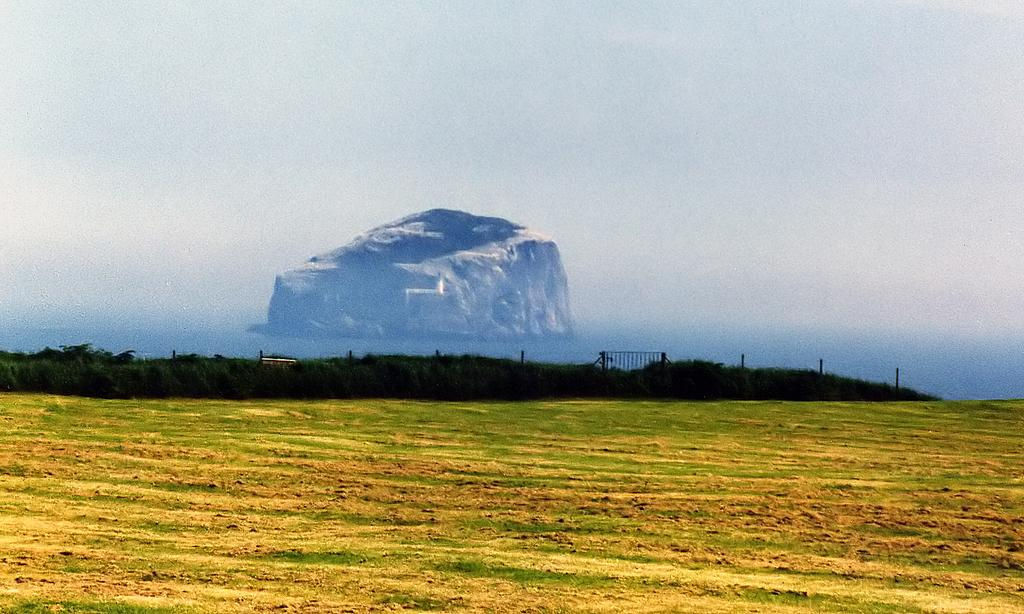What type of vegetation can be seen in the image? There is grass and bushes in the image. Are there any other natural elements present in the image? Yes, there is a rock in the background of the image. What can be seen in the sky in the image? The sky is visible in the background of the image. What type of eggnog is being served in the image? There is no eggnog present in the image; it features grass, bushes, a rock, and the sky. 